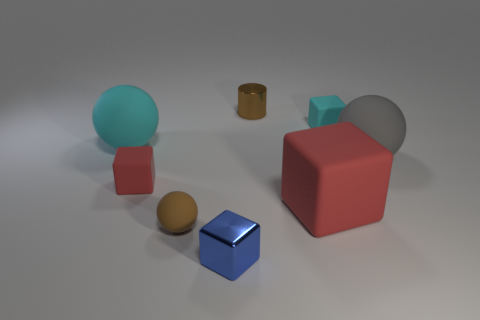What number of objects are either large red rubber cubes or cyan rubber spheres?
Make the answer very short. 2. What is the size of the brown rubber thing that is the same shape as the gray rubber object?
Make the answer very short. Small. The gray sphere is what size?
Make the answer very short. Large. Is the number of small brown shiny cylinders that are to the left of the small blue object greater than the number of tiny red cubes?
Your answer should be very brief. No. Are there any other things that are made of the same material as the tiny ball?
Your answer should be very brief. Yes. There is a shiny thing in front of the gray matte sphere; does it have the same color as the big object that is on the left side of the tiny metallic cylinder?
Offer a very short reply. No. There is a tiny brown object that is in front of the red thing that is to the left of the matte block that is in front of the tiny red thing; what is its material?
Make the answer very short. Rubber. Are there more cylinders than large brown objects?
Give a very brief answer. Yes. Is there anything else of the same color as the cylinder?
Offer a terse response. Yes. There is a brown object that is made of the same material as the tiny cyan block; what size is it?
Provide a short and direct response. Small. 